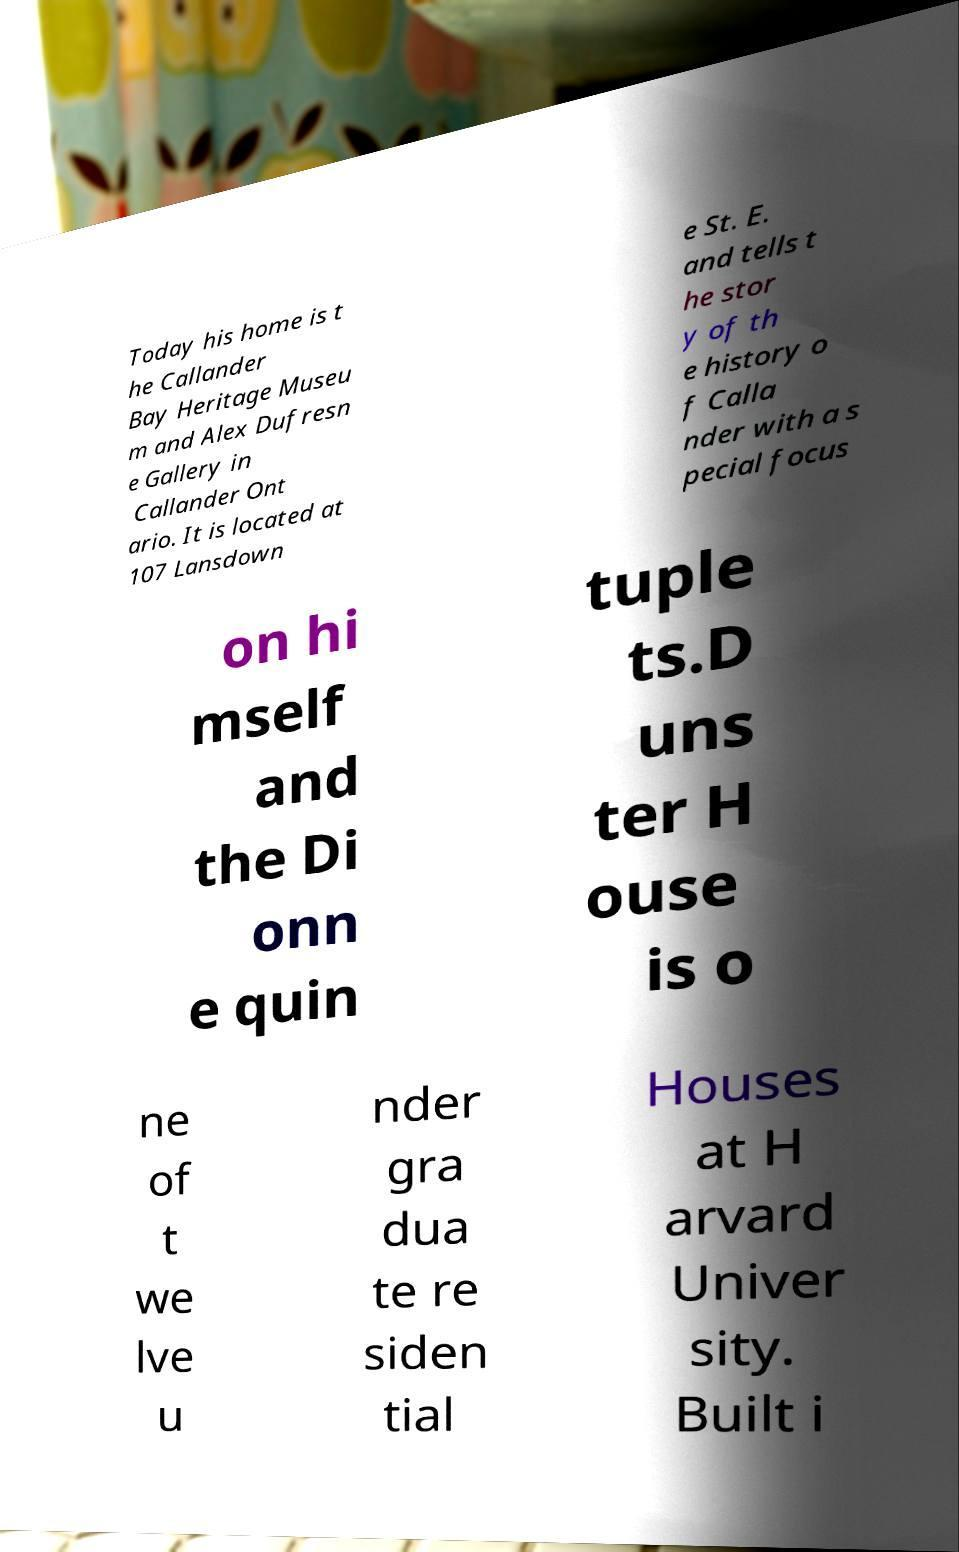What messages or text are displayed in this image? I need them in a readable, typed format. Today his home is t he Callander Bay Heritage Museu m and Alex Dufresn e Gallery in Callander Ont ario. It is located at 107 Lansdown e St. E. and tells t he stor y of th e history o f Calla nder with a s pecial focus on hi mself and the Di onn e quin tuple ts.D uns ter H ouse is o ne of t we lve u nder gra dua te re siden tial Houses at H arvard Univer sity. Built i 